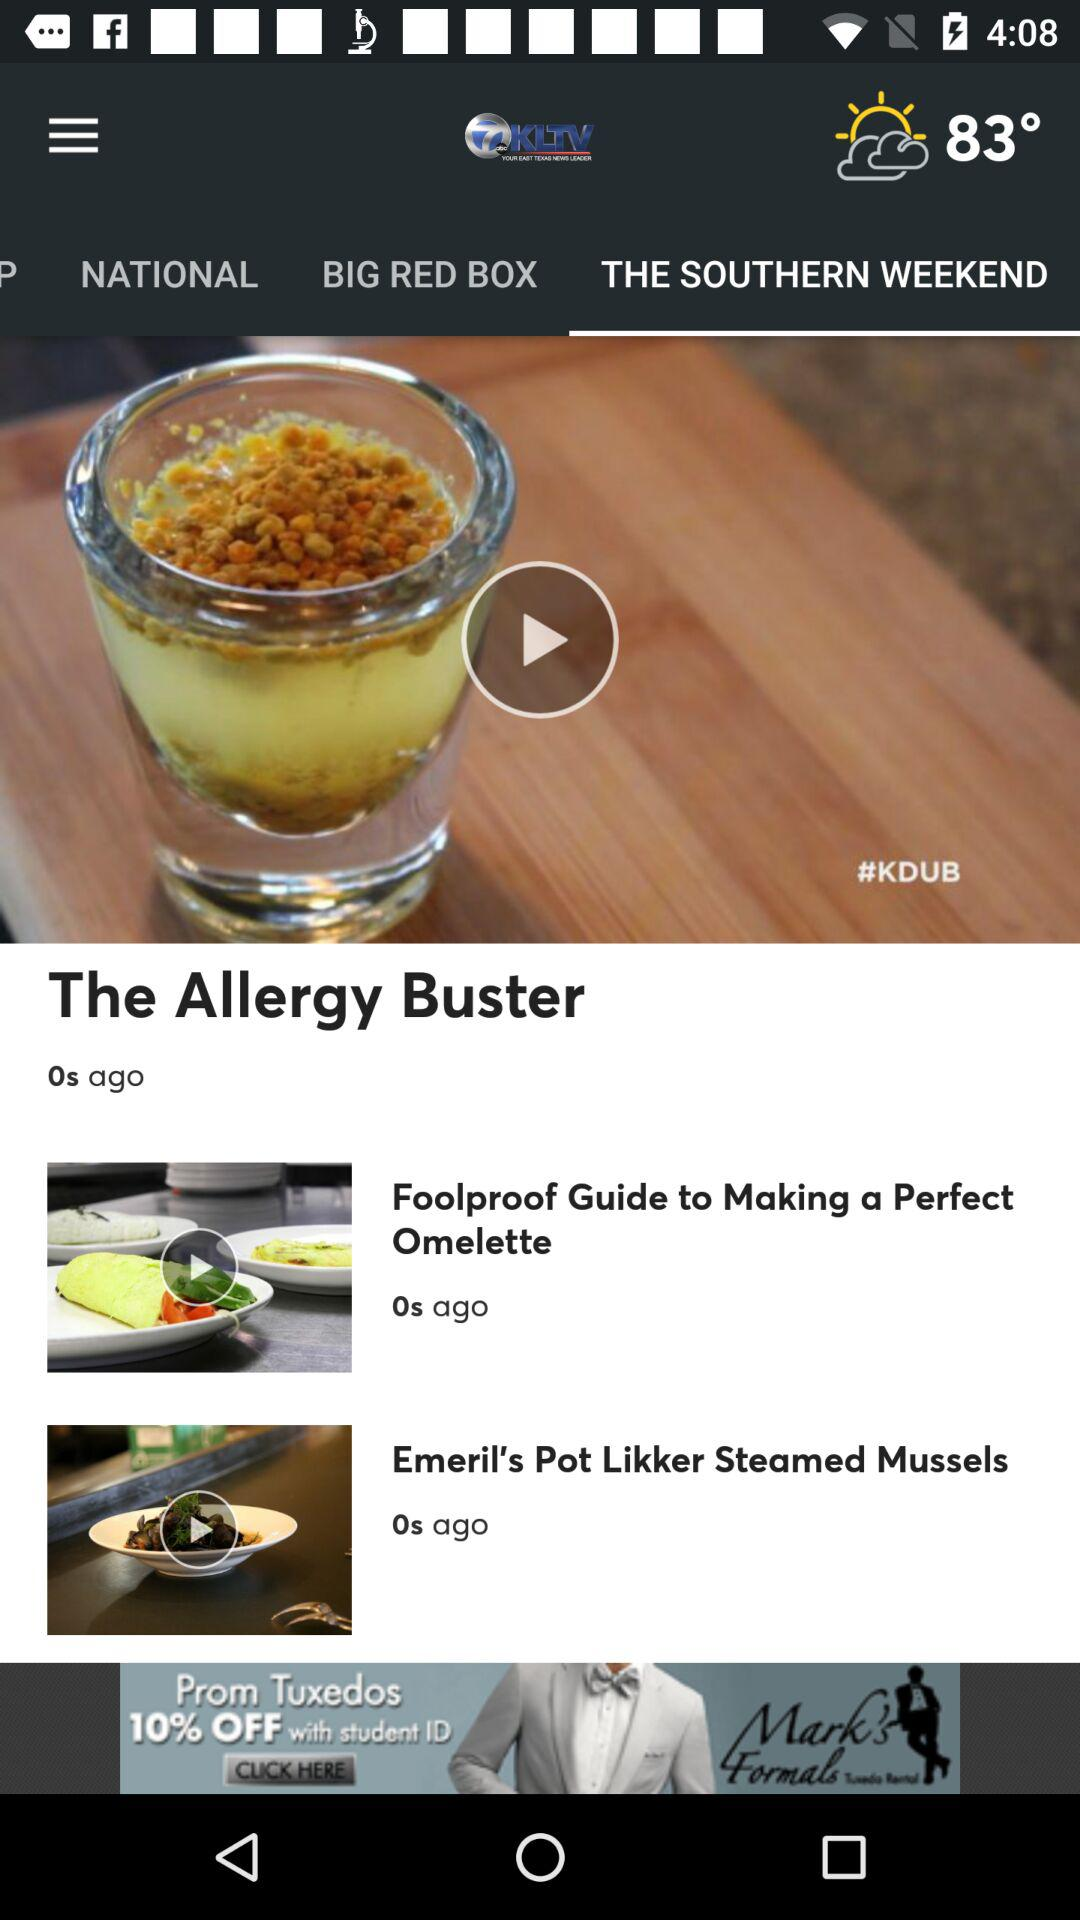How many degrees Fahrenheit is the current temperature?
Answer the question using a single word or phrase. 83° 